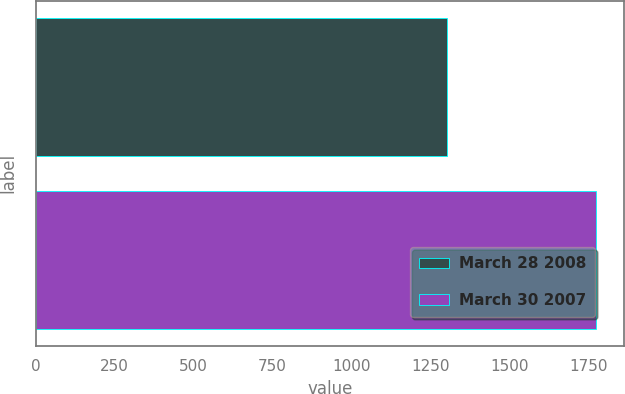Convert chart to OTSL. <chart><loc_0><loc_0><loc_500><loc_500><bar_chart><fcel>March 28 2008<fcel>March 30 2007<nl><fcel>1304<fcel>1775<nl></chart> 